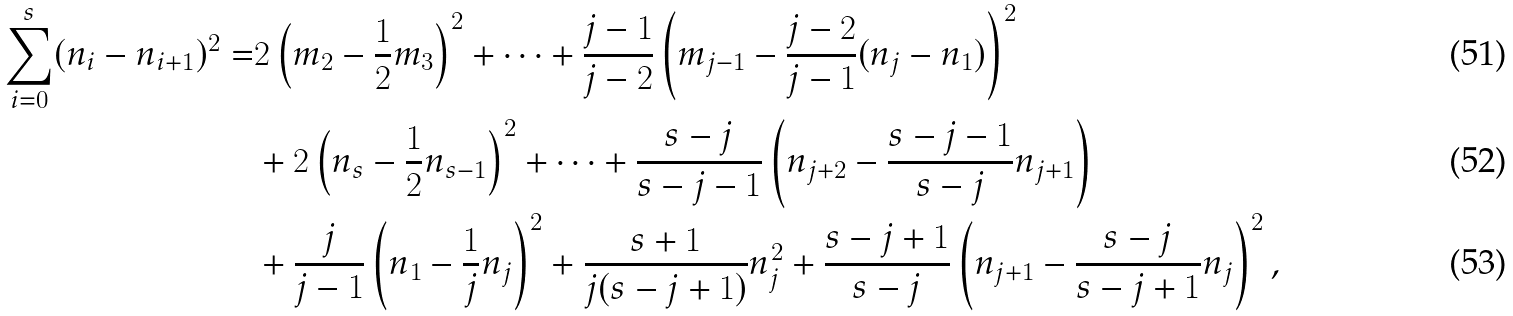<formula> <loc_0><loc_0><loc_500><loc_500>\sum _ { i = 0 } ^ { s } ( n _ { i } - n _ { i + 1 } ) ^ { 2 } = & 2 \left ( m _ { 2 } - \frac { 1 } { 2 } m _ { 3 } \right ) ^ { 2 } + \dots + \frac { j - 1 } { j - 2 } \left ( m _ { j - 1 } - \frac { j - 2 } { j - 1 } ( n _ { j } - n _ { 1 } ) \right ) ^ { 2 } \\ & + 2 \left ( n _ { s } - \frac { 1 } { 2 } n _ { s - 1 } \right ) ^ { 2 } + \dots + \frac { s - j } { s - j - 1 } \left ( n _ { j + 2 } - \frac { s - j - 1 } { s - j } n _ { j + 1 } \right ) \\ & + \frac { j } { j - 1 } \left ( n _ { 1 } - \frac { 1 } { j } n _ { j } \right ) ^ { 2 } + \frac { s + 1 } { j ( s - j + 1 ) } n _ { j } ^ { 2 } + \frac { s - j + 1 } { s - j } \left ( n _ { j + 1 } - \frac { s - j } { s - j + 1 } n _ { j } \right ) ^ { 2 } ,</formula> 